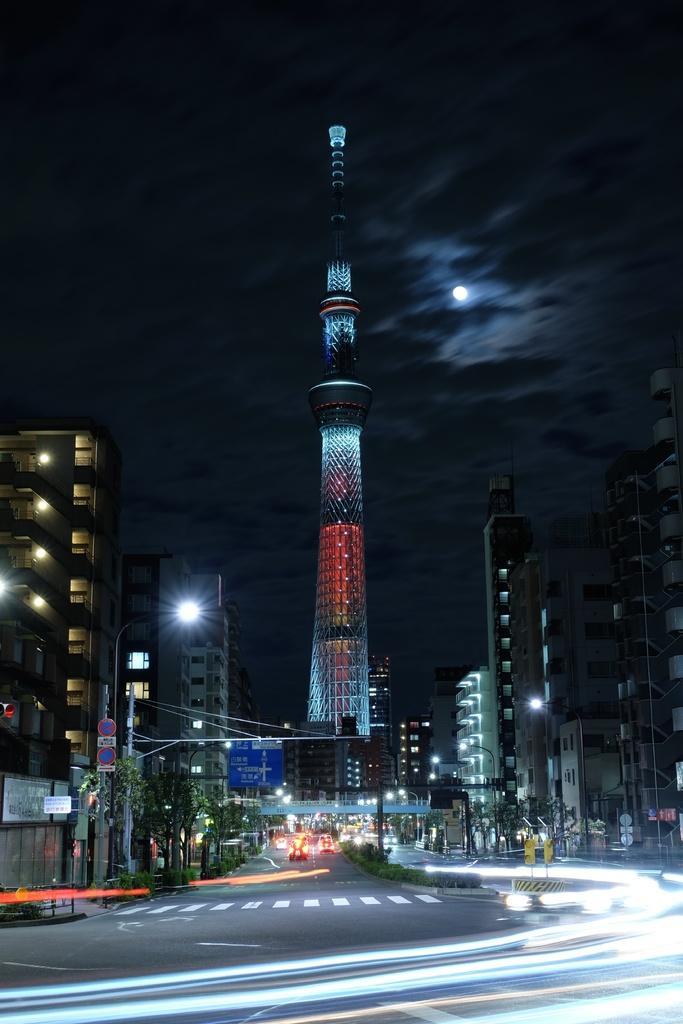Can you describe this image briefly? In this image there is a road. The vehicles are moving. There are buildings. There is a tall building with colorful lights in the middle. There are trees. There are street lights. There is a moon. There is a sky. 